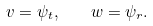Convert formula to latex. <formula><loc_0><loc_0><loc_500><loc_500>v = \psi _ { t } , \quad w = \psi _ { r } .</formula> 